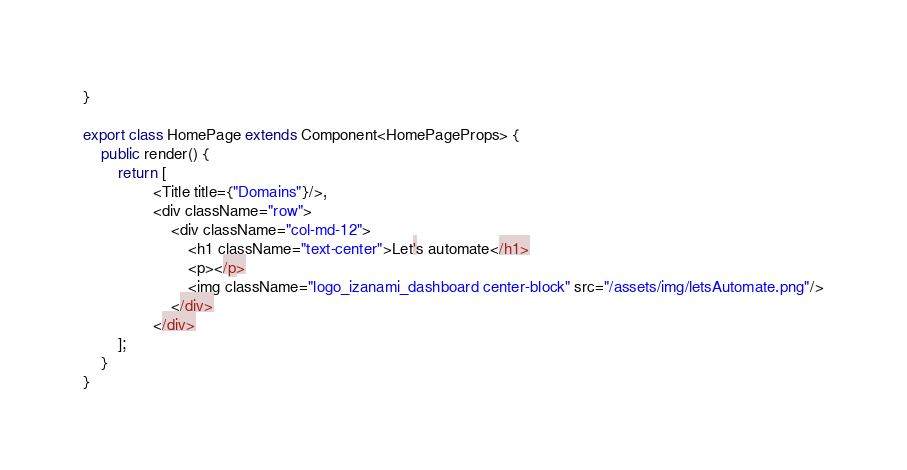Convert code to text. <code><loc_0><loc_0><loc_500><loc_500><_TypeScript_>
}

export class HomePage extends Component<HomePageProps> {
    public render() {
        return [
                <Title title={"Domains"}/>,
                <div className="row">
                    <div className="col-md-12">
                        <h1 className="text-center">Let's automate</h1>
                        <p></p>
                        <img className="logo_izanami_dashboard center-block" src="/assets/img/letsAutomate.png"/>
                    </div>
                </div>
        ];
    }
}</code> 